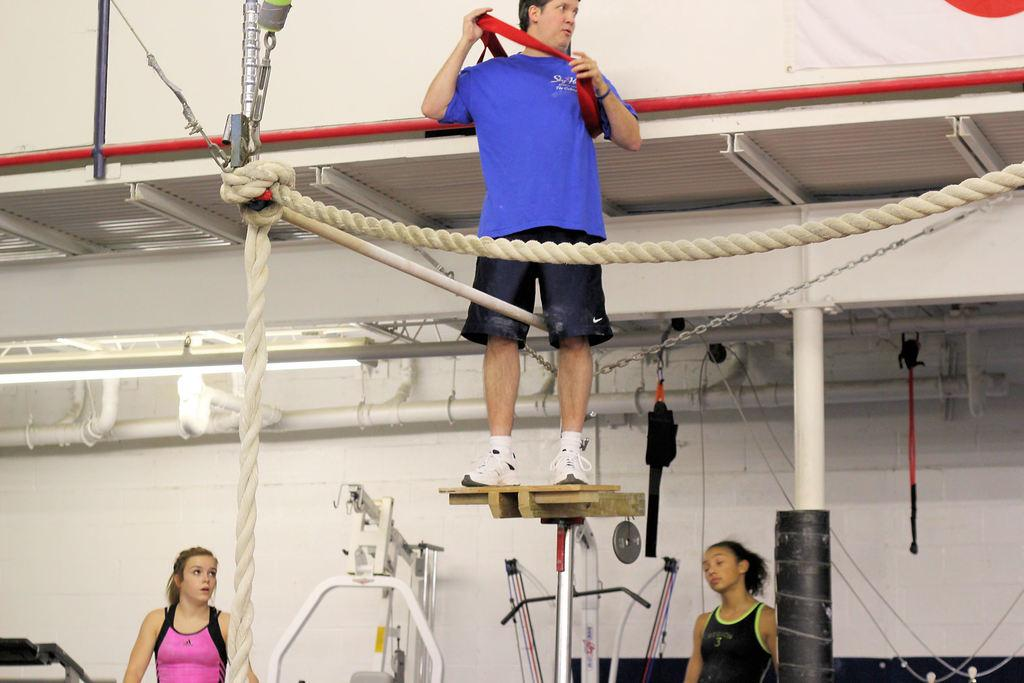How many people are in the image? There are three persons standing in the image. What is the position of one of the persons? One person is standing on a stand. What objects can be seen in the image related to suspension or support? There are ropes, a chain, and poles in the image. What type of structure is visible in the image? There is a wall in the image. What objects can be seen in the image related to plumbing or conduits? There are pipes in the image. What objects can be seen in the image related to illumination? There are lights in the image. What type of railway is visible in the image? There is no railway present in the image. Can you see any animals in the image that might be found in a zoo? There are no animals visible in the image, and the context does not suggest a zoo setting. 